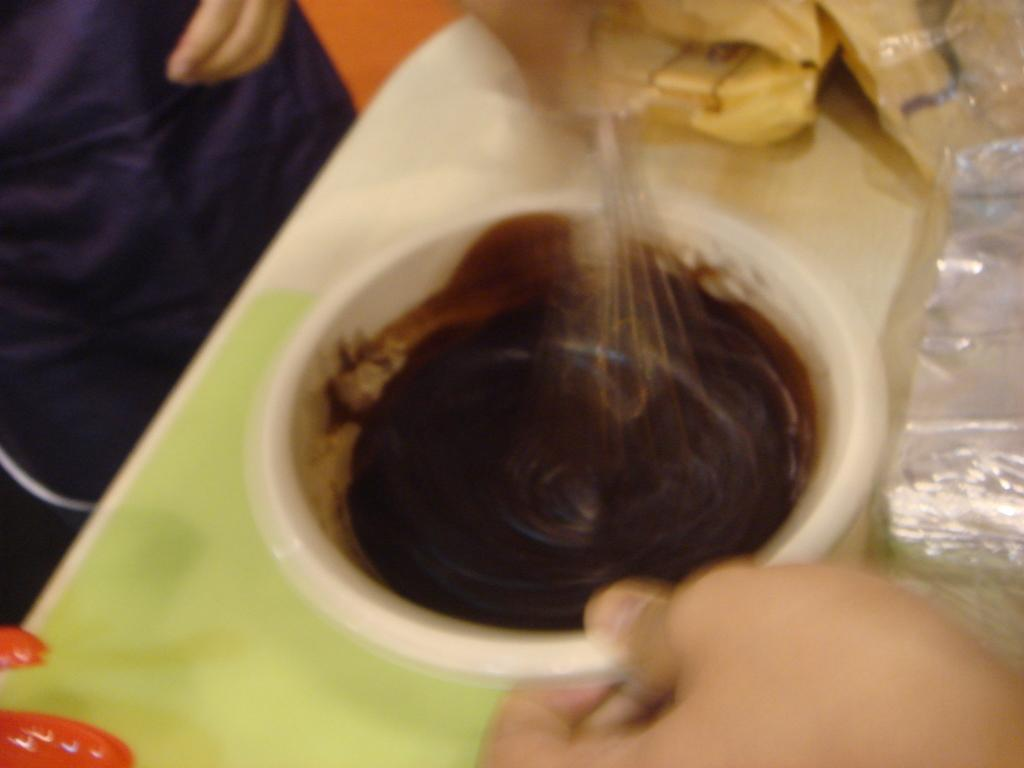What is in the bowl that is visible in the image? There is a bowl filled with food items in the image. What part of a person can be seen in the image? A human hand is visible in the image. What tool is present in the image? There is a beater in the image. What type of spoon is being used to draw circles in the image? There is no spoon or circle-drawing activity present in the image. 